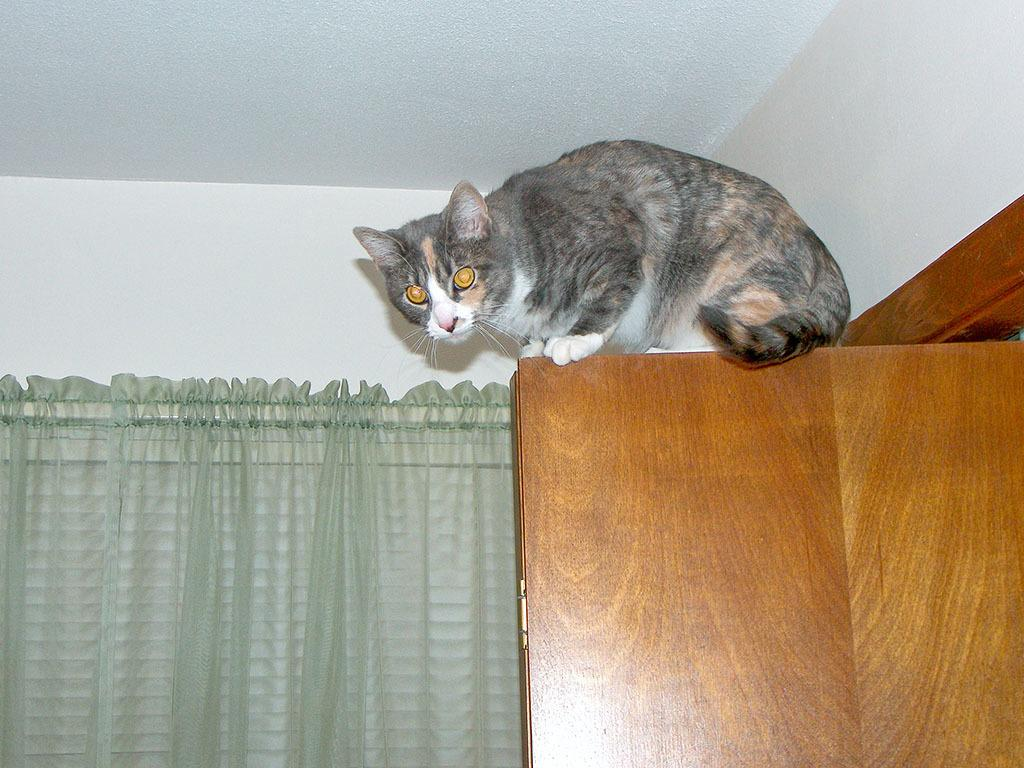What animal is present on the door in the image? There is a cat on the door in the image. On which side of the image is the cat located? The cat is on the right side of the image. What is on the left side of the image? There is a curtain on the left side of the image. What can be seen in the background of the image? There is a wall in the background of the image. How many cakes are being served on vacation in the square in the image? There are no cakes, vacation, or square present in the image; it features a cat on a door with a curtain and a wall in the background. 